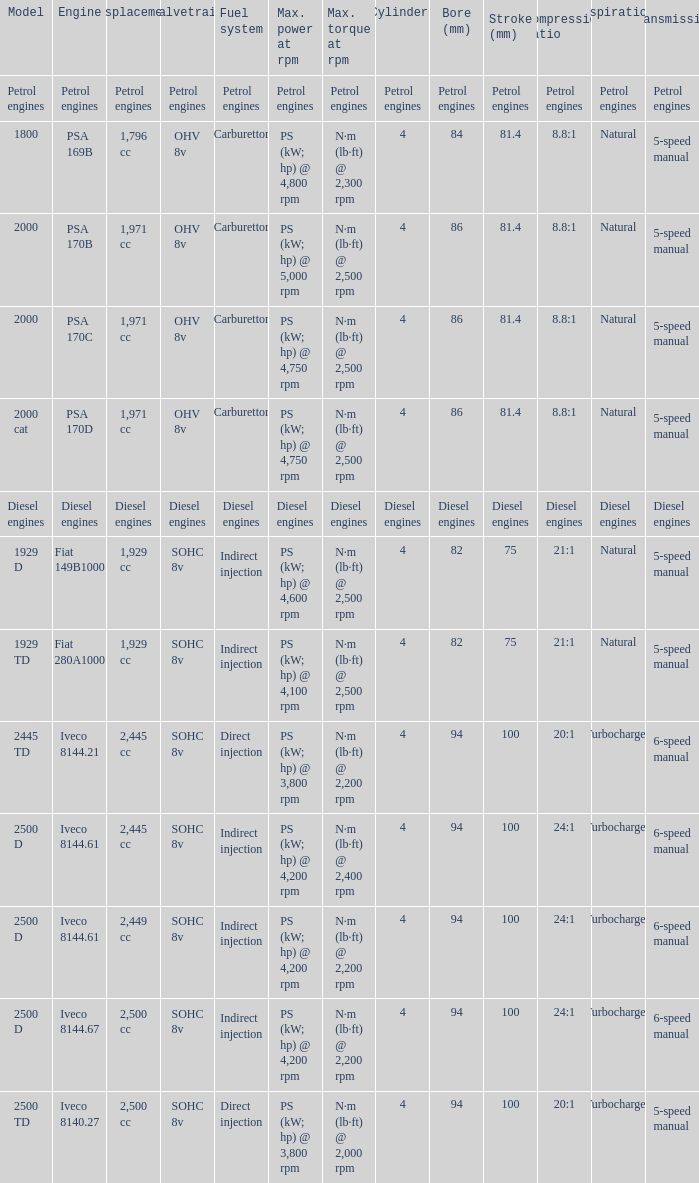What is the maximum torque that has 2,445 CC Displacement, and an Iveco 8144.61 engine? N·m (lb·ft) @ 2,400 rpm. 